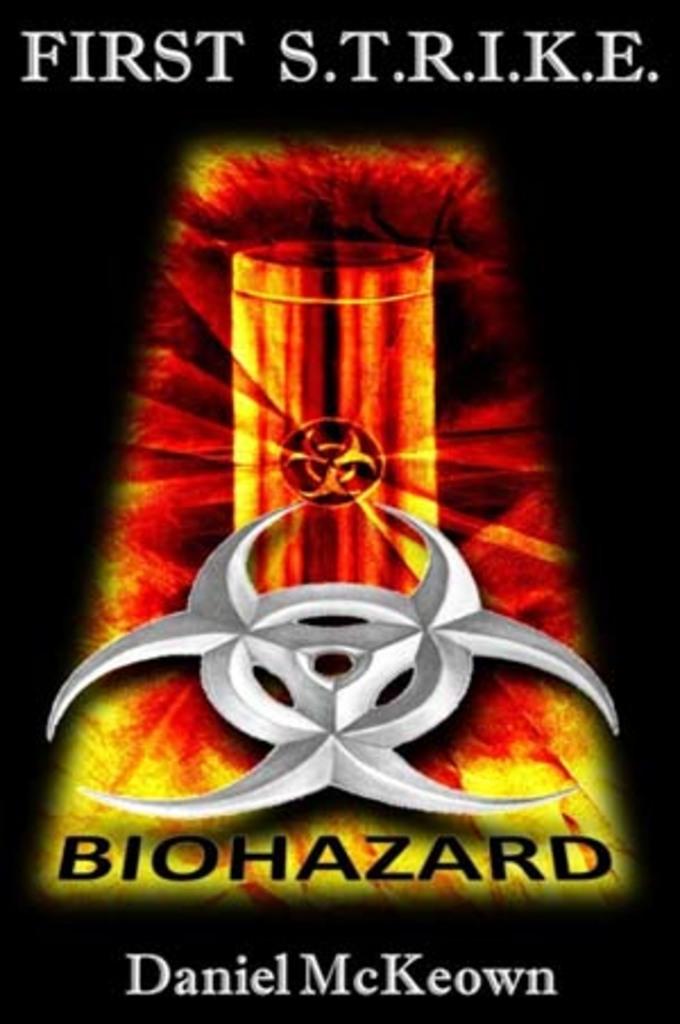What is the movie ad promoting?
Your answer should be compact. First s.t.r.i.k.e. biohazard. Who authored the first s.t.r.i.k.e.?
Offer a very short reply. Daniel mckeown. 